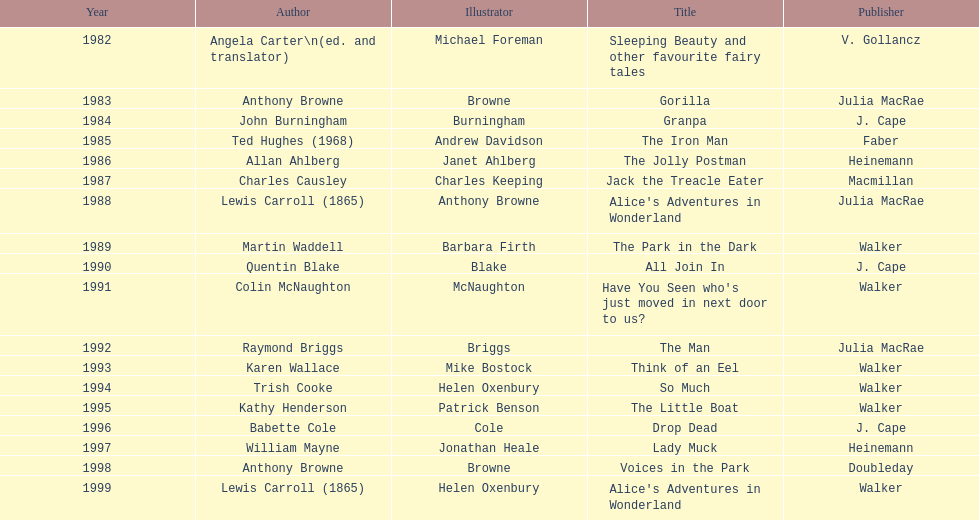Can you parse all the data within this table? {'header': ['Year', 'Author', 'Illustrator', 'Title', 'Publisher'], 'rows': [['1982', 'Angela Carter\\n(ed. and translator)', 'Michael Foreman', 'Sleeping Beauty and other favourite fairy tales', 'V. Gollancz'], ['1983', 'Anthony Browne', 'Browne', 'Gorilla', 'Julia MacRae'], ['1984', 'John Burningham', 'Burningham', 'Granpa', 'J. Cape'], ['1985', 'Ted Hughes (1968)', 'Andrew Davidson', 'The Iron Man', 'Faber'], ['1986', 'Allan Ahlberg', 'Janet Ahlberg', 'The Jolly Postman', 'Heinemann'], ['1987', 'Charles Causley', 'Charles Keeping', 'Jack the Treacle Eater', 'Macmillan'], ['1988', 'Lewis Carroll (1865)', 'Anthony Browne', "Alice's Adventures in Wonderland", 'Julia MacRae'], ['1989', 'Martin Waddell', 'Barbara Firth', 'The Park in the Dark', 'Walker'], ['1990', 'Quentin Blake', 'Blake', 'All Join In', 'J. Cape'], ['1991', 'Colin McNaughton', 'McNaughton', "Have You Seen who's just moved in next door to us?", 'Walker'], ['1992', 'Raymond Briggs', 'Briggs', 'The Man', 'Julia MacRae'], ['1993', 'Karen Wallace', 'Mike Bostock', 'Think of an Eel', 'Walker'], ['1994', 'Trish Cooke', 'Helen Oxenbury', 'So Much', 'Walker'], ['1995', 'Kathy Henderson', 'Patrick Benson', 'The Little Boat', 'Walker'], ['1996', 'Babette Cole', 'Cole', 'Drop Dead', 'J. Cape'], ['1997', 'William Mayne', 'Jonathan Heale', 'Lady Muck', 'Heinemann'], ['1998', 'Anthony Browne', 'Browne', 'Voices in the Park', 'Doubleday'], ['1999', 'Lewis Carroll (1865)', 'Helen Oxenbury', "Alice's Adventures in Wonderland", 'Walker']]} What is the count of titles listed for the year 1991? 1. 